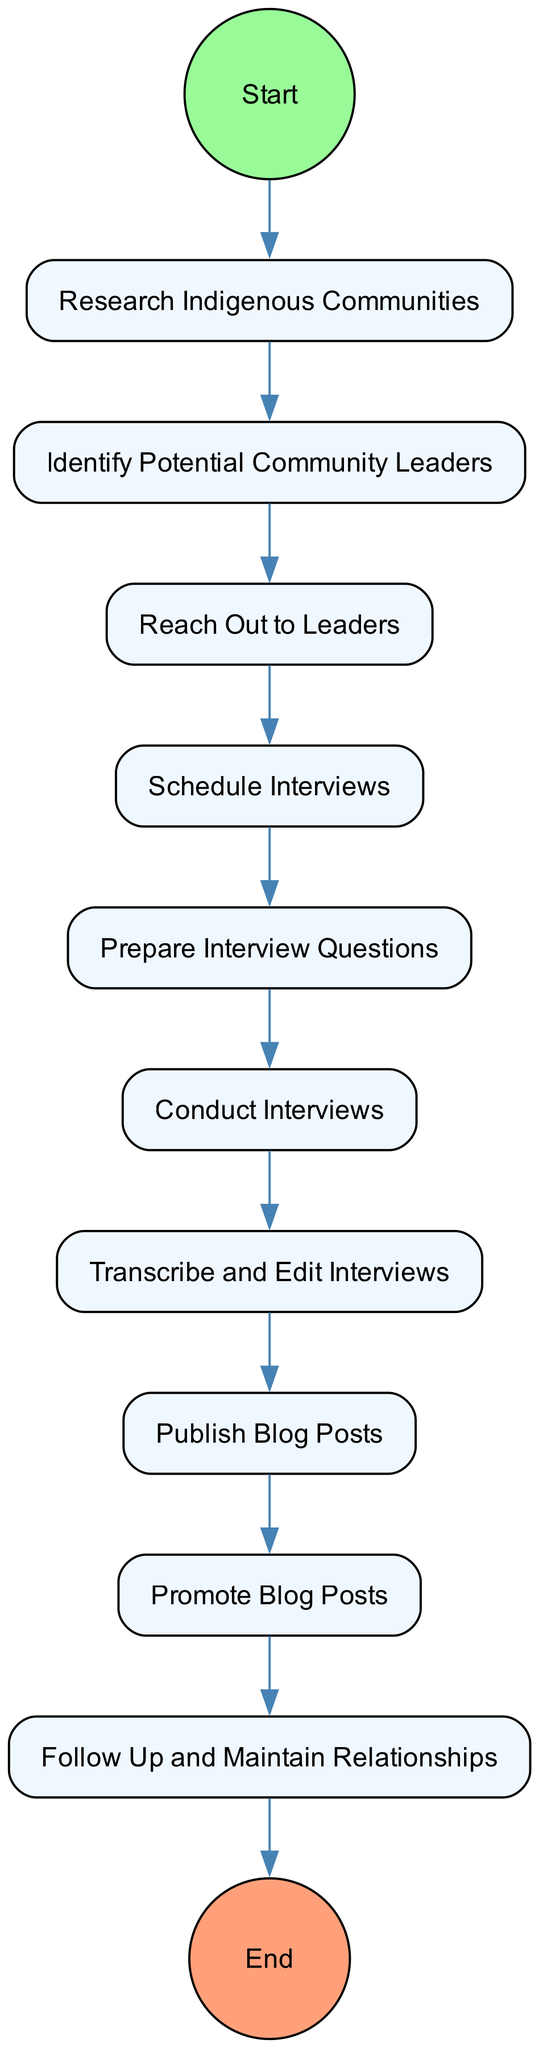What is the first activity in the diagram? The first activity is identified by the position right after the 'Start' node. According to the diagram, the first activity listed is "Research Indigenous Communities."
Answer: Research Indigenous Communities How many activities are there in total? To find the total number of activities, we can count each activity listed in the diagram. There are ten activities depicted.
Answer: 10 Which activity comes before "Conduct Interviews"? By tracing the flow in the diagram leading to "Conduct Interviews," we can see the preceding activity is "Prepare Interview Questions."
Answer: Prepare Interview Questions What is the last activity in the diagram? The last activity can be found by looking at the edge connected to the 'End' node, which follows the last activity. The last activity listed is "Publish Blog Posts."
Answer: Publish Blog Posts How do "Schedule Interviews" and "Reach Out to Leaders" relate? These two activities are sequential activities in the flow of the diagram. "Reach Out to Leaders" must be completed before "Schedule Interviews" can begin, indicating a direct dependency.
Answer: Sequential activities What activity directly follows "Transcribe and Edit Interviews"? The next activity is determined by tracing the flow from "Transcribe and Edit Interviews," which leads to "Publish Blog Posts."
Answer: Publish Blog Posts Which activity involves developing questions? The activity concerned with developing questions can be identified as "Prepare Interview Questions," which explicitly mentions this task in its description.
Answer: Prepare Interview Questions What relationship exists between "Promote Blog Posts" and "Follow Up and Maintain Relationships"? These two activities represent distinct but related tasks that occur sequentially in the diagram. "Promote Blog Posts" comes first, and then "Follow Up and Maintain Relationships" follows.
Answer: Sequential activities 